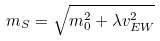<formula> <loc_0><loc_0><loc_500><loc_500>m _ { S } = \sqrt { m _ { 0 } ^ { 2 } + \lambda v _ { E W } ^ { 2 } }</formula> 